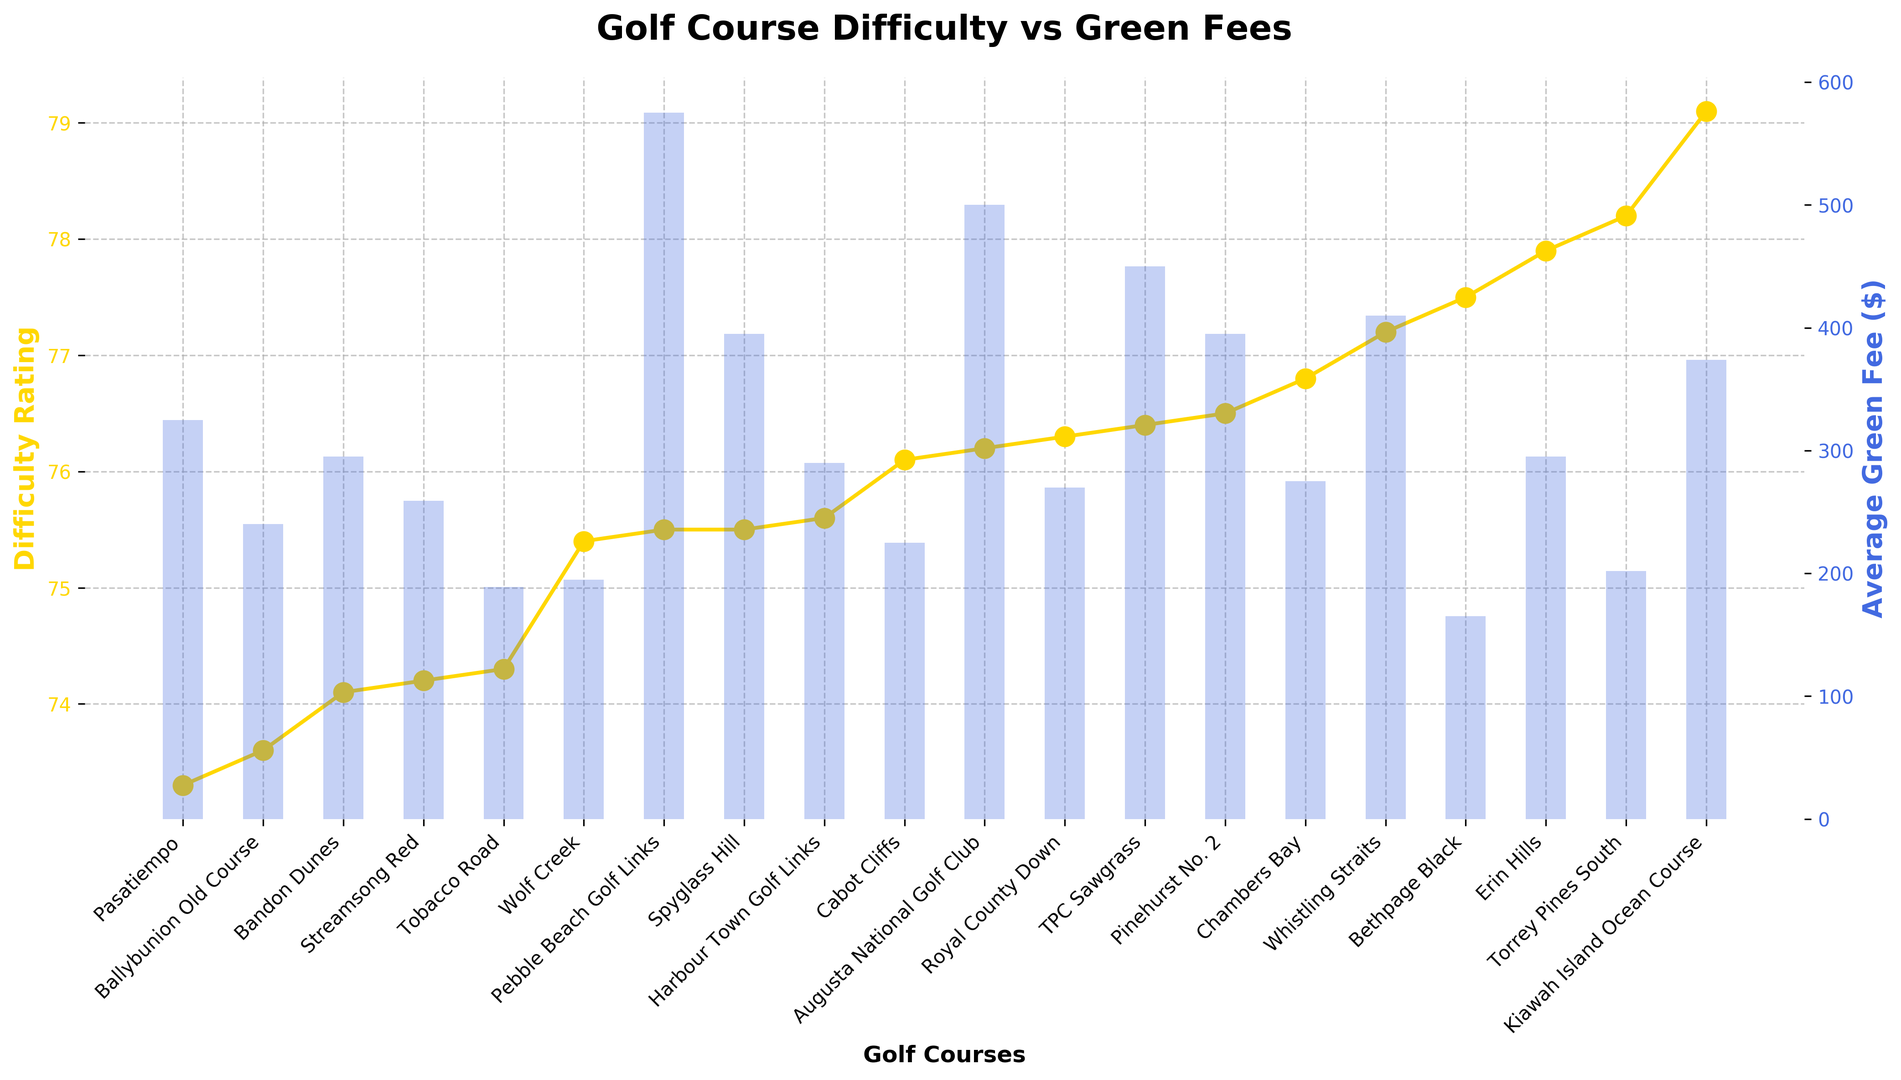What is the highest difficulty rating among the courses listed? Identify the peak point on the Difficulty Rating line plot, which represents the highest value among the difficulty ratings for the golf courses.
Answer: 79.1 Which course has the lowest average green fee? Look for the shortest bar in the bar chart representing the Average Green Fee.
Answer: Bethpage Black What is the difference in average green fees between Pebble Beach Golf Links and Torrey Pines South? Locate the bars for Pebble Beach Golf Links and Torrey Pines South, read their heights, and subtract the green fee of Torrey Pines South from that of Pebble Beach Golf Links (575 - 202).
Answer: 373 Which course appears at the intersection of highest difficulty rating and the lowest average green fee? Assess both plots simultaneously to find the course with the highest Difficulty Rating and also having the lowest bar for Average Green Fee.
Answer: Torrey Pines South How does the difficulty rating of Augusta National Golf Club compare to that of TPC Sawgrass? Compare the heights of the points on the line plot for both golf courses.
Answer: Augusta National Golf Club is slightly less difficult than TPC Sawgrass Which course has the highest green fee among those with a difficulty rating above 76? Identify the courses on the line plot with difficulty ratings above 76, then check the corresponding bars on the bar chart to find the highest.
Answer: Pebble Beach Golf Links Are there any courses that have the same difficulty rating? Check the line plot for any marker points that align horizontally.
Answer: Yes, Pebble Beach Golf Links and Spyglass Hill What is the average difficulty rating of all courses listed? Add all the difficulty ratings together and divide by the total number of courses (20). [(75.5 + 76.2 + ... + 76.3) / 20]
Answer: 75.89 Which course notably stands out for having a relatively high difficulty rating but low green fee? Look for courses with high points on the Difficulty Rating plot but shorter bars on the Average Green Fee bar chart.
Answer: Bethpage Black Which course has a higher difficulty rating, Erin Hills or Pinehurst No. 2, and by how much? Compare the heights of the points on the line plot for Erin Hills and Pinehurst No. 2, then measure the difference (77.9 - 76.5).
Answer: Erin Hills by 1.4 